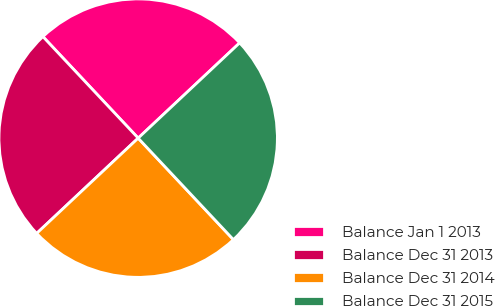Convert chart to OTSL. <chart><loc_0><loc_0><loc_500><loc_500><pie_chart><fcel>Balance Jan 1 2013<fcel>Balance Dec 31 2013<fcel>Balance Dec 31 2014<fcel>Balance Dec 31 2015<nl><fcel>25.0%<fcel>25.0%<fcel>25.0%<fcel>25.0%<nl></chart> 